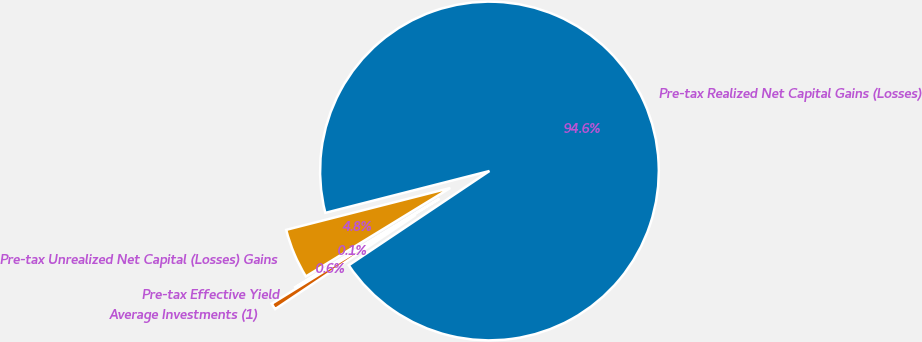Convert chart to OTSL. <chart><loc_0><loc_0><loc_500><loc_500><pie_chart><fcel>Pre-tax Realized Net Capital Gains (Losses)<fcel>Pre-tax Unrealized Net Capital (Losses) Gains<fcel>Pre-tax Effective Yield<fcel>Average Investments (1)<nl><fcel>94.58%<fcel>4.77%<fcel>0.05%<fcel>0.6%<nl></chart> 